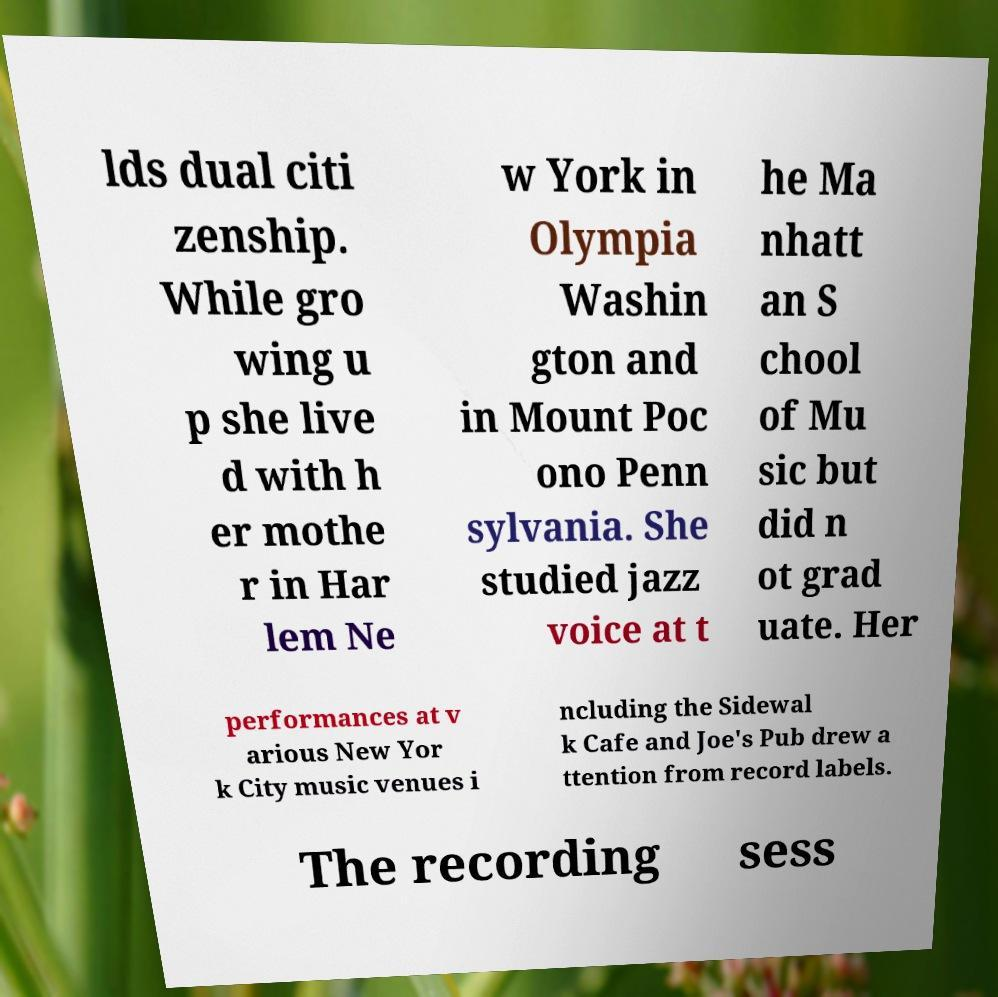Could you extract and type out the text from this image? lds dual citi zenship. While gro wing u p she live d with h er mothe r in Har lem Ne w York in Olympia Washin gton and in Mount Poc ono Penn sylvania. She studied jazz voice at t he Ma nhatt an S chool of Mu sic but did n ot grad uate. Her performances at v arious New Yor k City music venues i ncluding the Sidewal k Cafe and Joe's Pub drew a ttention from record labels. The recording sess 